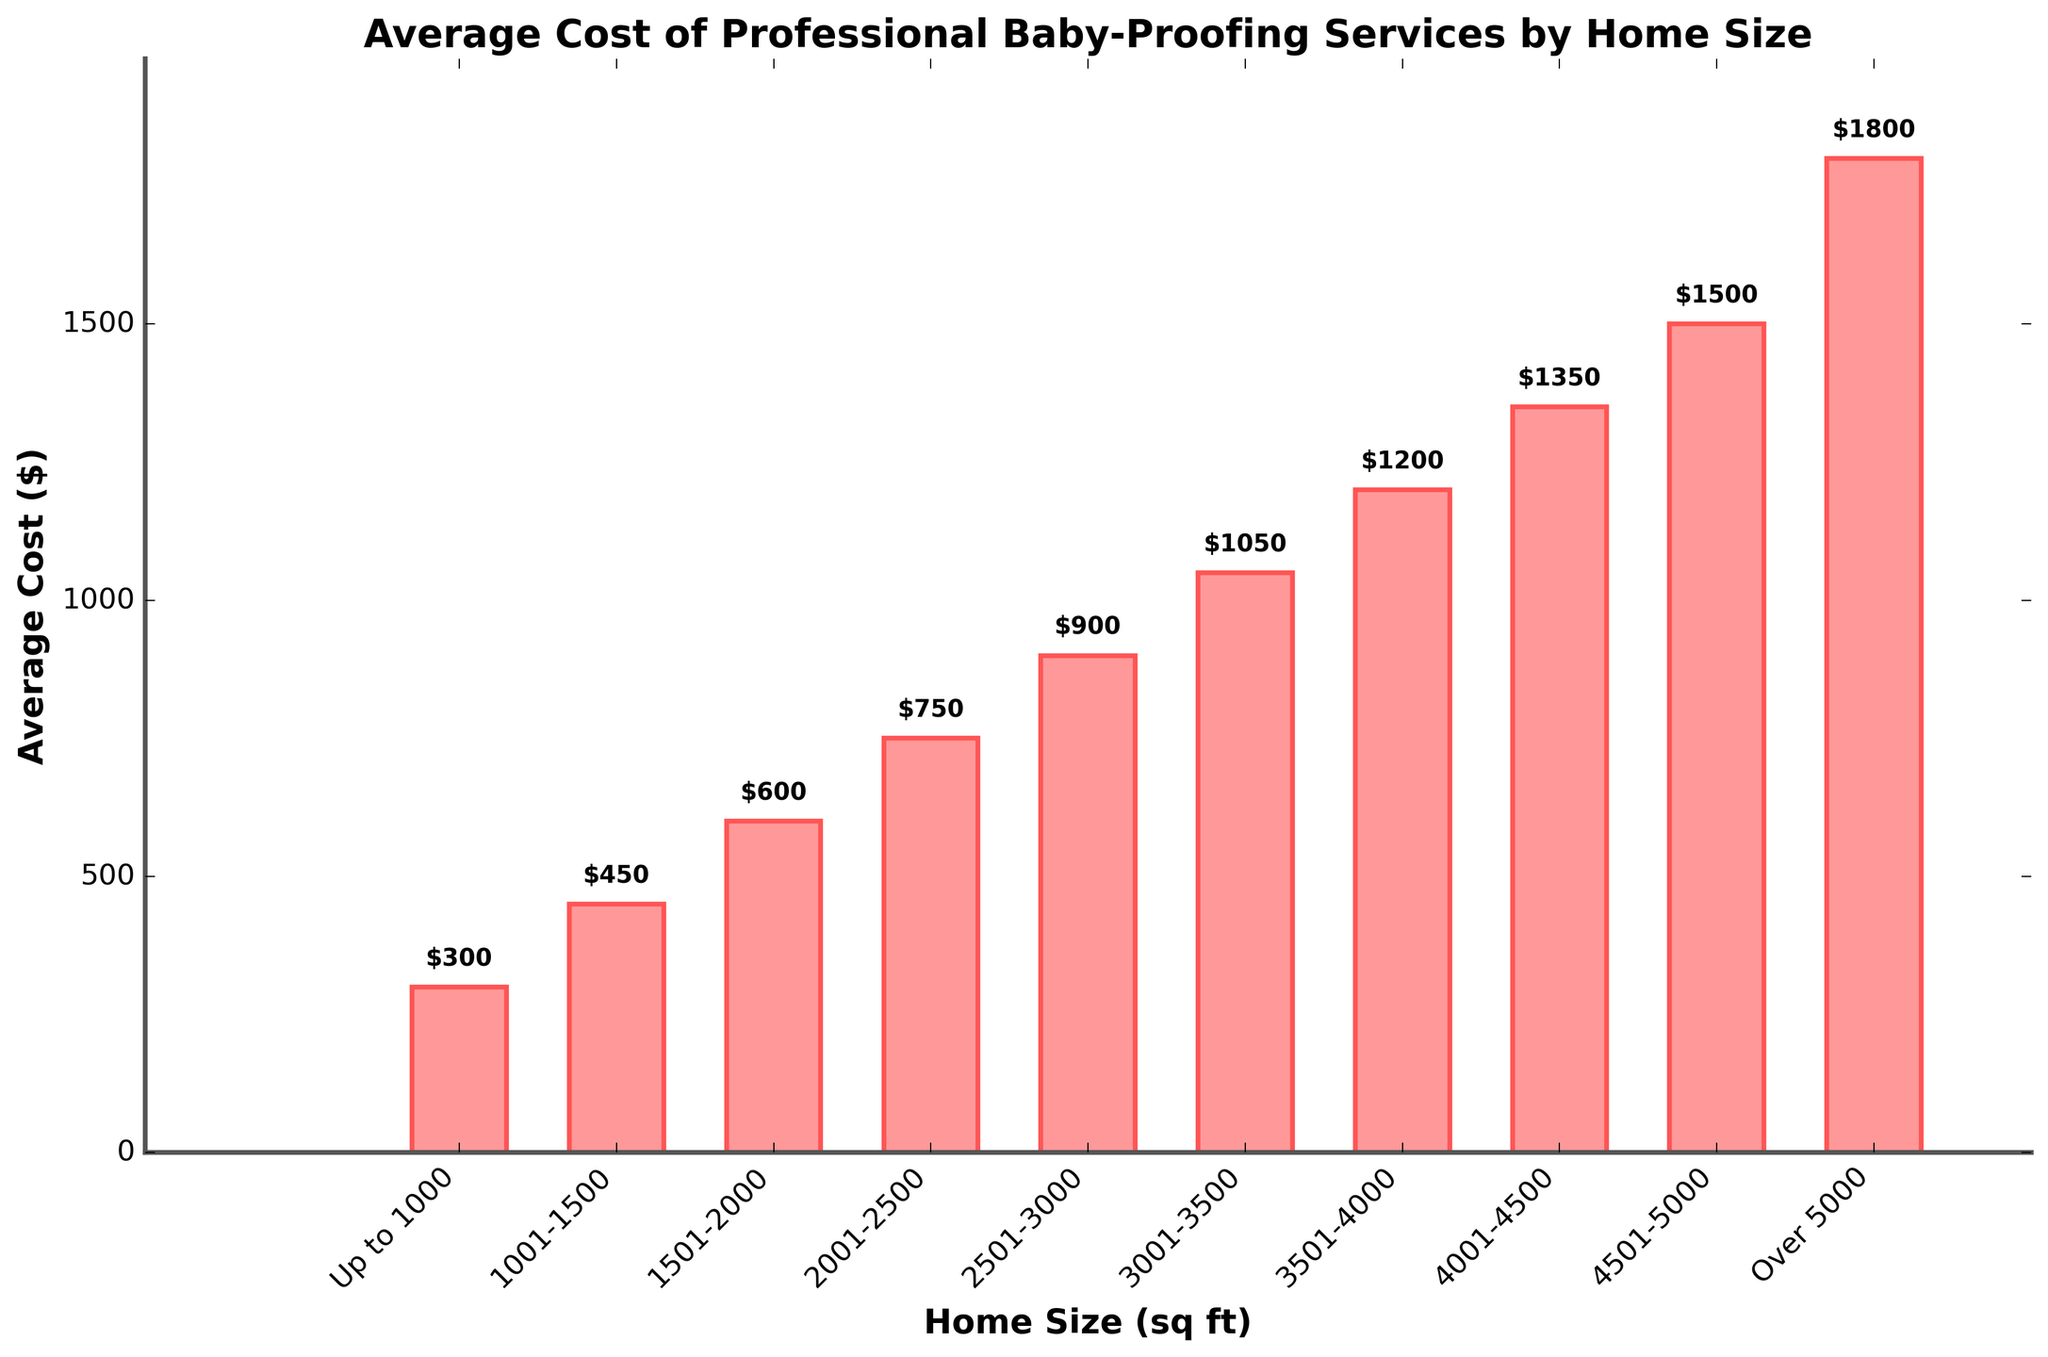What is the average cost of professional baby-proofing services for homes sized 3501-4000 sq ft? Look at the bar corresponding to the '3501-4000' sq ft home size and read the height of the bar, which is labeled as $1200.
Answer: $1200 Which home size category has the highest average cost for baby-proofing services? Identify the tallest bar in the chart, which corresponds to the 'Over 5000' sq ft home size category, with a cost of $1800.
Answer: Over 5000 How much more does it cost to baby-proof a home of 2501-3000 sq ft compared to a home of up to 1000 sq ft? Subtract the average cost for the 'Up to 1000' sq ft category ($300) from the '2501-3000' sq ft category ($900). The difference is $900 - $300 = $600.
Answer: $600 What is the total cost of professionally baby-proofing homes of all sizes listed in the chart? Sum the costs of all home size categories: $300 + $450 + $600 + $750 + $900 + $1050 + $1200 + $1350 + $1500 + $1800. This gives $9900.
Answer: $9900 Which home size categories have an average cost less than $1000 and how many such categories are there? Identify the bars with heights less than $1000: the 'Up to 1000', '1001-1500', '1501-2000', '2001-2500', and '2501-3000' sq ft categories. There are 5 such categories.
Answer: 5 Is the average cost of baby-proofing a home sized 1501-2000 sq ft greater than those for homes sized 1001-1500 sq ft and 2001-2500 sq ft combined? Compare the cost for '1501-2000' sq ft ($600) with the sum of '1001-1500' sq ft ($450) and '2001-2500' sq ft ($750). $600 is less than $450 + $750 = $1200.
Answer: No Which home size category has an average cost of professional baby-proofing services closest to $1000? Compare the bars around the $1000 mark and identify the closest. The '2501-3000' sq ft category has a cost of $900, and the '3001-3500' sq ft category has a cost of $1050. The '2501-3000' sq ft category is closer.
Answer: 2501-3000 What is the difference in the average cost of baby-proofing services between the home size categories 2001-2500 sq ft and 4501-5000 sq ft? Subtract the cost for the '2001-2500' sq ft category ($750) from the '4501-5000' sq ft category ($1500). The difference is $1500 - $750 = $750.
Answer: $750 For which home size categories do average costs increase by exactly $150 as compared to the previous category? Check for increments of $150 by comparing each category with the one before. '1001-1500' sq ft ($450) to '1501-2000' sq ft ($600), '2001-2500' sq ft ($750) to '2501-3000' sq ft ($900), and '3001-3500' sq ft ($1050) to '3501-4000' sq ft ($1200) fit this criteria. There are 3 such pairs.
Answer: 3 pairs What is the visual appearance of the highest cost bar in terms of color and position? The highest bar, corresponding to the 'Over 5000' sq ft category, is colored in a shade of red and positioned at the far right of the chart.
Answer: Red, far right 